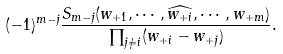Convert formula to latex. <formula><loc_0><loc_0><loc_500><loc_500>( - 1 ) ^ { m - j } \frac { S _ { m - j } ( w _ { + 1 } , \cdots , \widehat { w _ { + i } } , \cdots , w _ { + m } ) } { \prod _ { j \neq i } ( w _ { + i } - w _ { + j } ) } .</formula> 